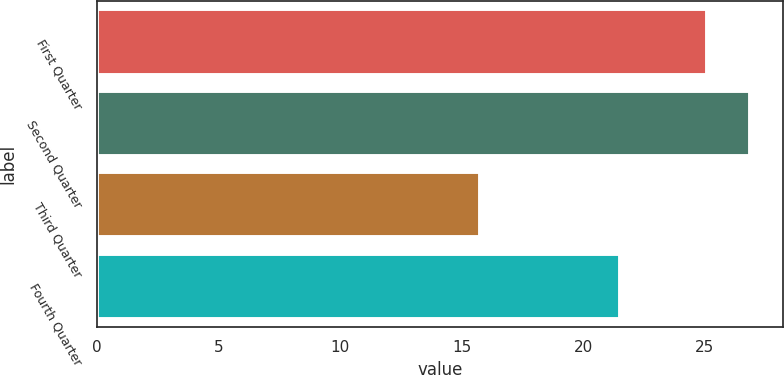Convert chart to OTSL. <chart><loc_0><loc_0><loc_500><loc_500><bar_chart><fcel>First Quarter<fcel>Second Quarter<fcel>Third Quarter<fcel>Fourth Quarter<nl><fcel>25.1<fcel>26.89<fcel>15.77<fcel>21.51<nl></chart> 